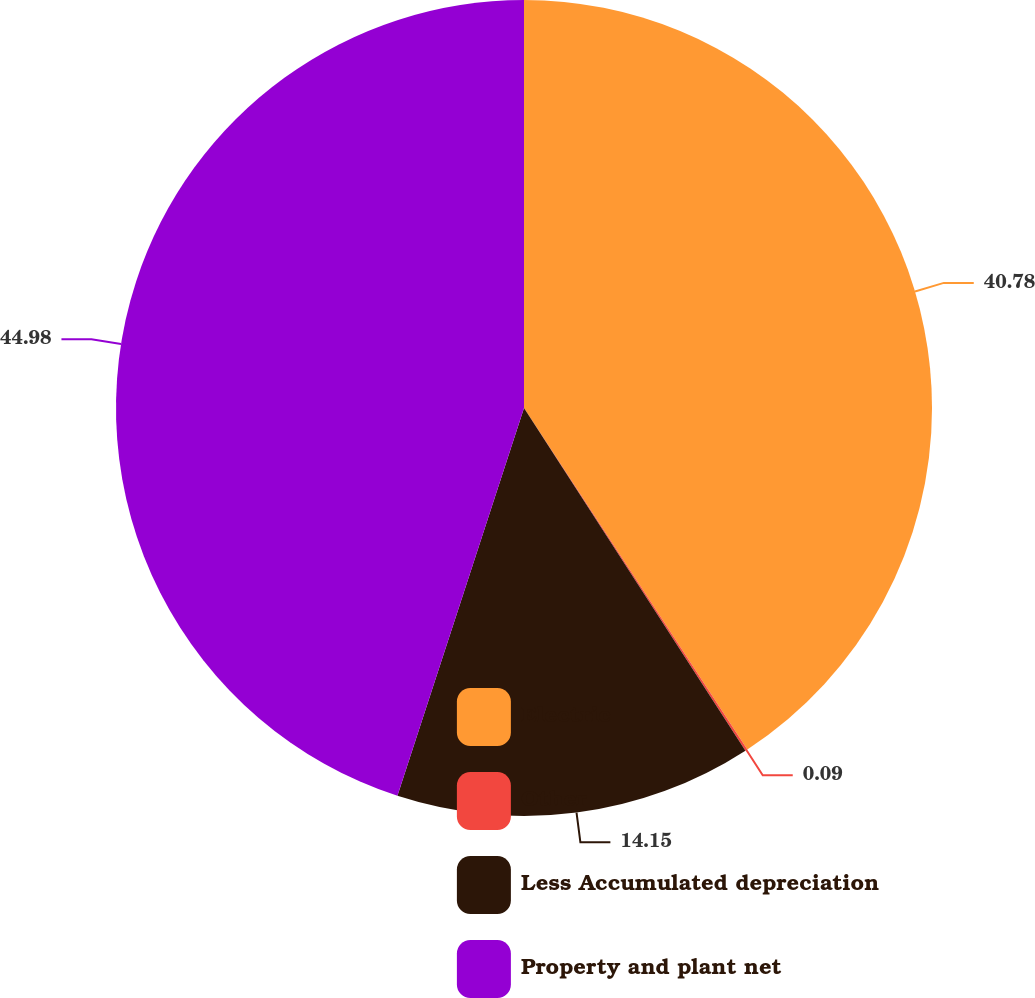Convert chart. <chart><loc_0><loc_0><loc_500><loc_500><pie_chart><fcel>Electric<fcel>Other<fcel>Less Accumulated depreciation<fcel>Property and plant net<nl><fcel>40.78%<fcel>0.09%<fcel>14.15%<fcel>44.98%<nl></chart> 